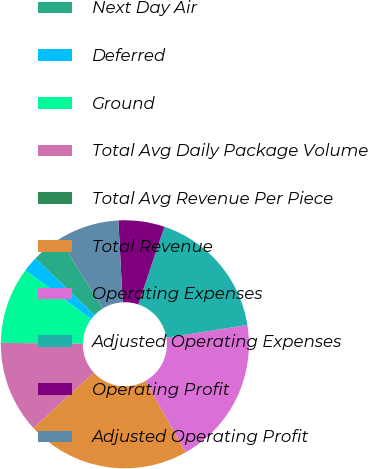Convert chart. <chart><loc_0><loc_0><loc_500><loc_500><pie_chart><fcel>Next Day Air<fcel>Deferred<fcel>Ground<fcel>Total Avg Daily Package Volume<fcel>Total Avg Revenue Per Piece<fcel>Total Revenue<fcel>Operating Expenses<fcel>Adjusted Operating Expenses<fcel>Operating Profit<fcel>Adjusted Operating Profit<nl><fcel>4.0%<fcel>2.0%<fcel>9.99%<fcel>11.99%<fcel>0.01%<fcel>21.34%<fcel>19.34%<fcel>17.35%<fcel>6.0%<fcel>7.99%<nl></chart> 